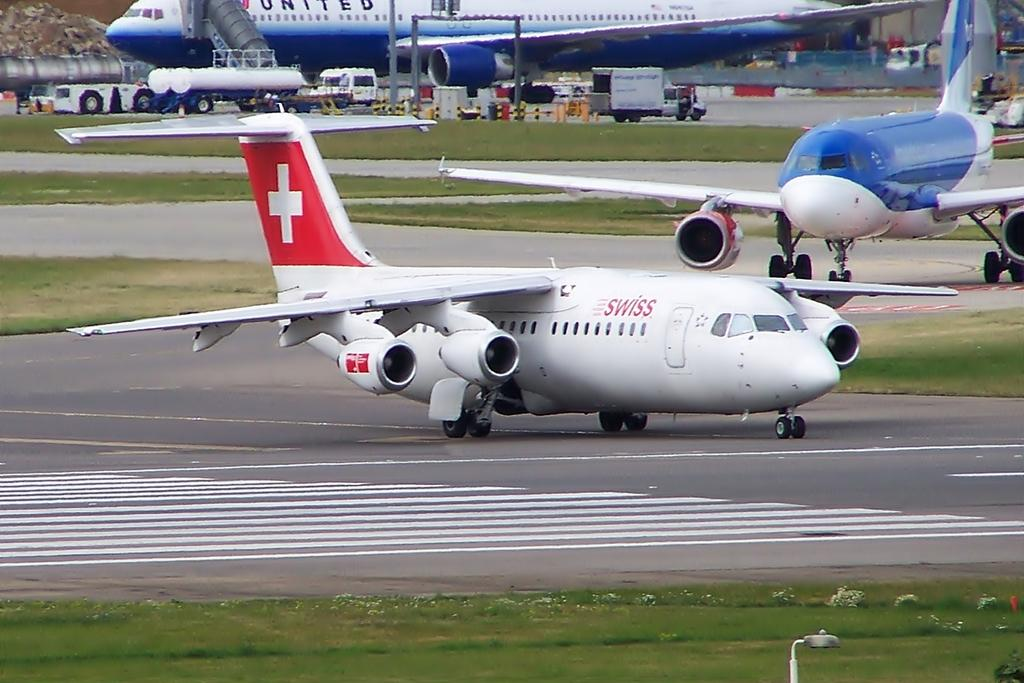<image>
Present a compact description of the photo's key features. A white Swiss jet plane on the tarmac with the swiss flag on the tail. 